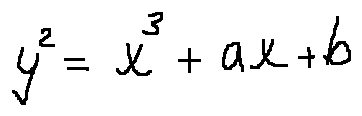<formula> <loc_0><loc_0><loc_500><loc_500>y ^ { 2 } = x ^ { 3 } + a x + b</formula> 